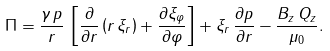Convert formula to latex. <formula><loc_0><loc_0><loc_500><loc_500>\Pi = \frac { \gamma \, p } { r } \, \left [ \frac { \partial } { \partial r } \left ( r \, \xi _ { r } \right ) + \frac { \partial \xi _ { \varphi } } { \partial \varphi } \right ] + \xi _ { r } \, \frac { \partial p } { \partial r } - \frac { B _ { z } \, Q _ { z } } { \mu _ { 0 } } .</formula> 